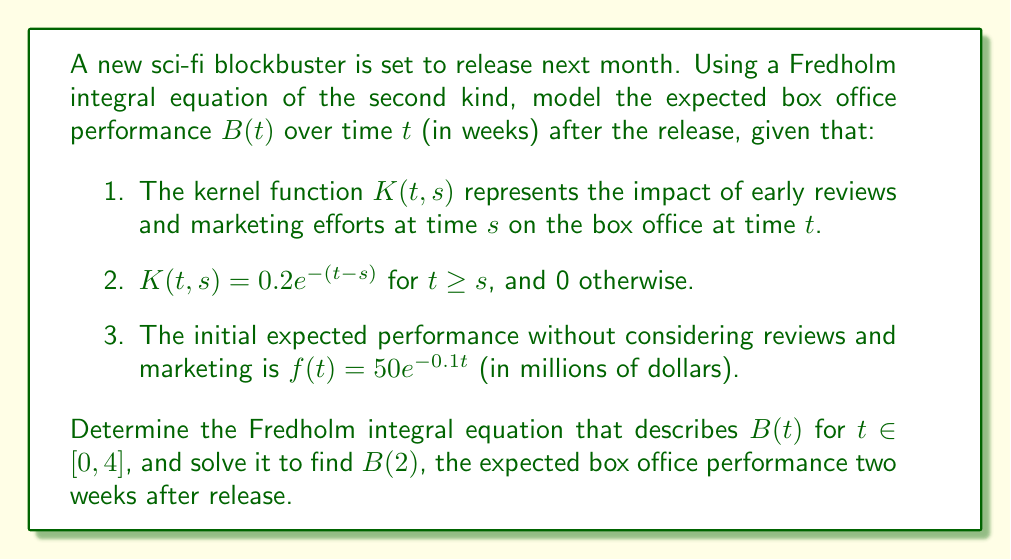Provide a solution to this math problem. Let's approach this step-by-step:

1) The general form of a Fredholm integral equation of the second kind is:

   $$B(t) = f(t) + \lambda \int_a^b K(t,s)B(s)ds$$

   where $\lambda$ is a constant, typically 1.

2) In our case, $a=0$, $b=4$, $\lambda=1$, and we have:

   $$B(t) = 50e^{-0.1t} + \int_0^t 0.2e^{-(t-s)}B(s)ds$$

3) To solve this, we can use the Laplace transform method. Let $\mathcal{L}\{B(t)\} = \bar{B}(p)$. Taking the Laplace transform of both sides:

   $$\bar{B}(p) = \frac{50}{p+0.1} + 0.2\bar{B}(p)\frac{1}{p+1}$$

4) Solving for $\bar{B}(p)$:

   $$\bar{B}(p) = \frac{50(p+1)}{(p+0.1)(p+1) - 0.2} = \frac{50(p+1)}{p^2 + 1.1p - 0.1}$$

5) The inverse Laplace transform gives us:

   $$B(t) = \frac{50}{1.2}(e^{0.1t} - e^{-t})$$

6) To find $B(2)$, we simply substitute $t=2$:

   $$B(2) = \frac{50}{1.2}(e^{0.2} - e^{-2})$$

7) Calculating this value:

   $$B(2) \approx 54.97$$ million dollars
Answer: $54.97$ million dollars 